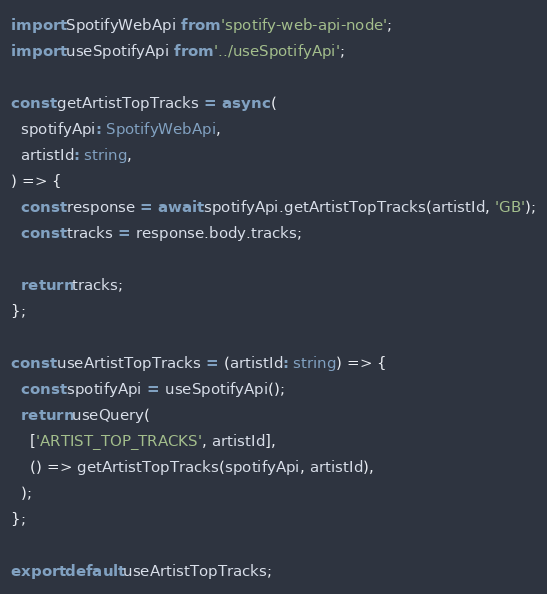Convert code to text. <code><loc_0><loc_0><loc_500><loc_500><_TypeScript_>import SpotifyWebApi from 'spotify-web-api-node';
import useSpotifyApi from '../useSpotifyApi';

const getArtistTopTracks = async (
  spotifyApi: SpotifyWebApi,
  artistId: string,
) => {
  const response = await spotifyApi.getArtistTopTracks(artistId, 'GB');
  const tracks = response.body.tracks;

  return tracks;
};

const useArtistTopTracks = (artistId: string) => {
  const spotifyApi = useSpotifyApi();
  return useQuery(
    ['ARTIST_TOP_TRACKS', artistId],
    () => getArtistTopTracks(spotifyApi, artistId),
  );
};

export default useArtistTopTracks;
</code> 